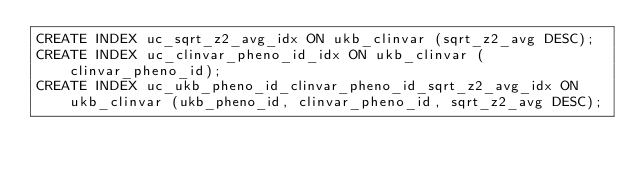<code> <loc_0><loc_0><loc_500><loc_500><_SQL_>CREATE INDEX uc_sqrt_z2_avg_idx ON ukb_clinvar (sqrt_z2_avg DESC);
CREATE INDEX uc_clinvar_pheno_id_idx ON ukb_clinvar (clinvar_pheno_id);
CREATE INDEX uc_ukb_pheno_id_clinvar_pheno_id_sqrt_z2_avg_idx ON ukb_clinvar (ukb_pheno_id, clinvar_pheno_id, sqrt_z2_avg DESC);
</code> 